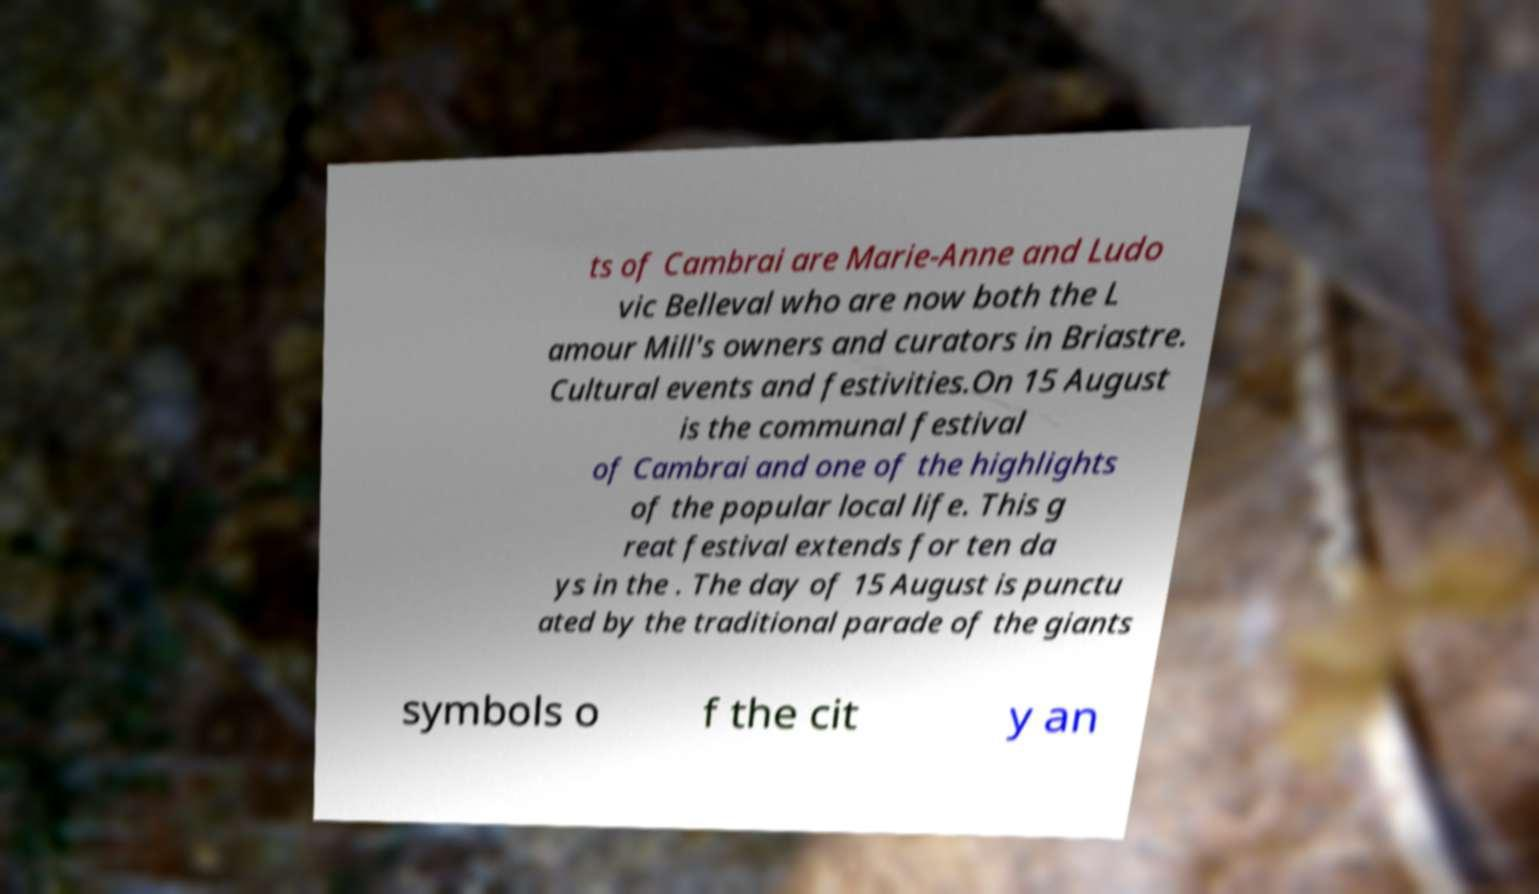For documentation purposes, I need the text within this image transcribed. Could you provide that? ts of Cambrai are Marie-Anne and Ludo vic Belleval who are now both the L amour Mill's owners and curators in Briastre. Cultural events and festivities.On 15 August is the communal festival of Cambrai and one of the highlights of the popular local life. This g reat festival extends for ten da ys in the . The day of 15 August is punctu ated by the traditional parade of the giants symbols o f the cit y an 